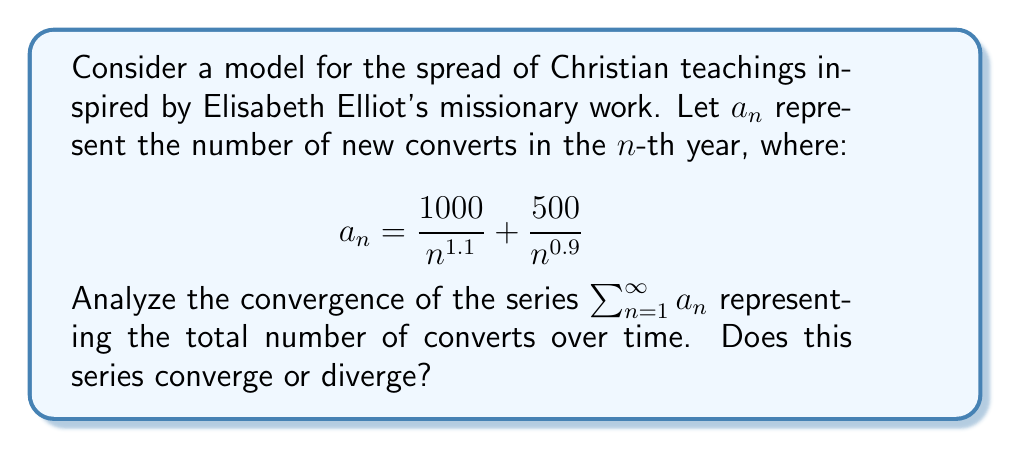Show me your answer to this math problem. To analyze the convergence of the series $\sum_{n=1}^{\infty} a_n$, we'll use the comparison test and p-series test.

1) First, let's consider each term separately:
   $\frac{1000}{n^{1.1}}$ and $\frac{500}{n^{0.9}}$

2) For $\frac{1000}{n^{1.1}}$:
   This is a p-series with $p = 1.1 > 1$, so $\sum_{n=1}^{\infty} \frac{1000}{n^{1.1}}$ converges.

3) For $\frac{500}{n^{0.9}}$:
   This is a p-series with $p = 0.9 < 1$, so $\sum_{n=1}^{\infty} \frac{500}{n^{0.9}}$ diverges.

4) Now, we have:
   $\sum_{n=1}^{\infty} a_n = \sum_{n=1}^{\infty} (\frac{1000}{n^{1.1}} + \frac{500}{n^{0.9}})$

5) We can split this into two series:
   $\sum_{n=1}^{\infty} \frac{1000}{n^{1.1}} + \sum_{n=1}^{\infty} \frac{500}{n^{0.9}}$

6) The first series converges, but the second series diverges.

7) By the sum rule for series, if one series in a sum of series diverges, the entire sum diverges.

Therefore, the series $\sum_{n=1}^{\infty} a_n$ diverges.
Answer: The series diverges. 